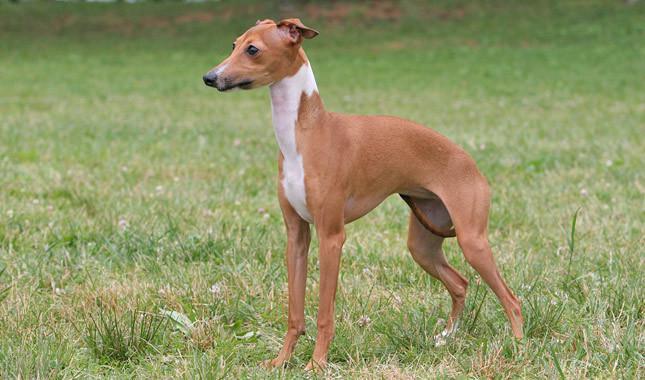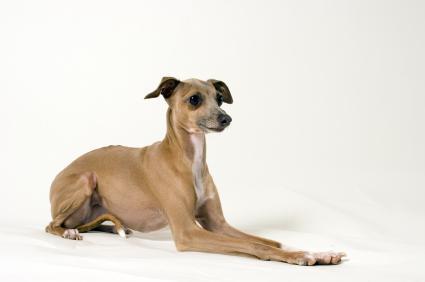The first image is the image on the left, the second image is the image on the right. For the images displayed, is the sentence "In one of the images, there is a brown and white dog standing in grass" factually correct? Answer yes or no. Yes. 